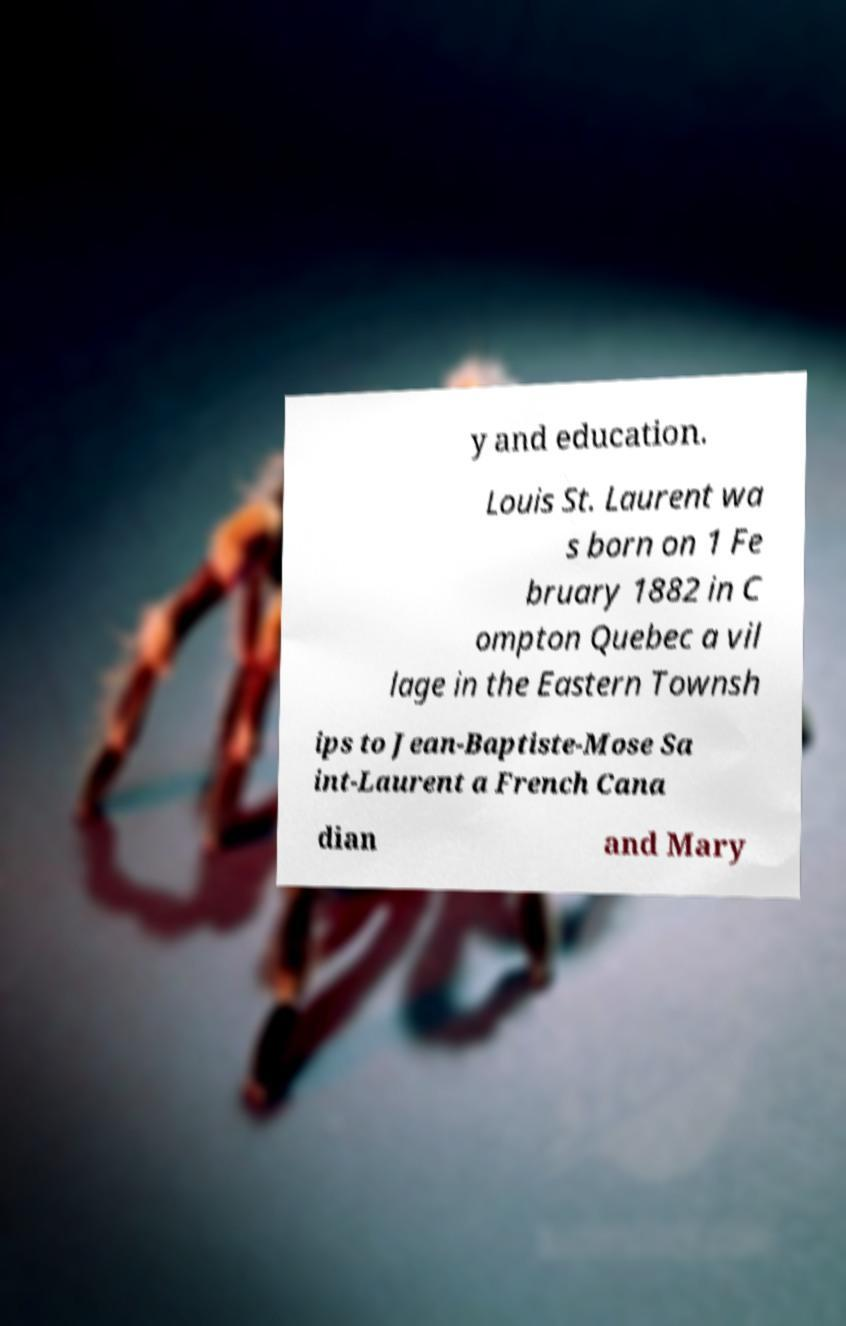There's text embedded in this image that I need extracted. Can you transcribe it verbatim? y and education. Louis St. Laurent wa s born on 1 Fe bruary 1882 in C ompton Quebec a vil lage in the Eastern Townsh ips to Jean-Baptiste-Mose Sa int-Laurent a French Cana dian and Mary 